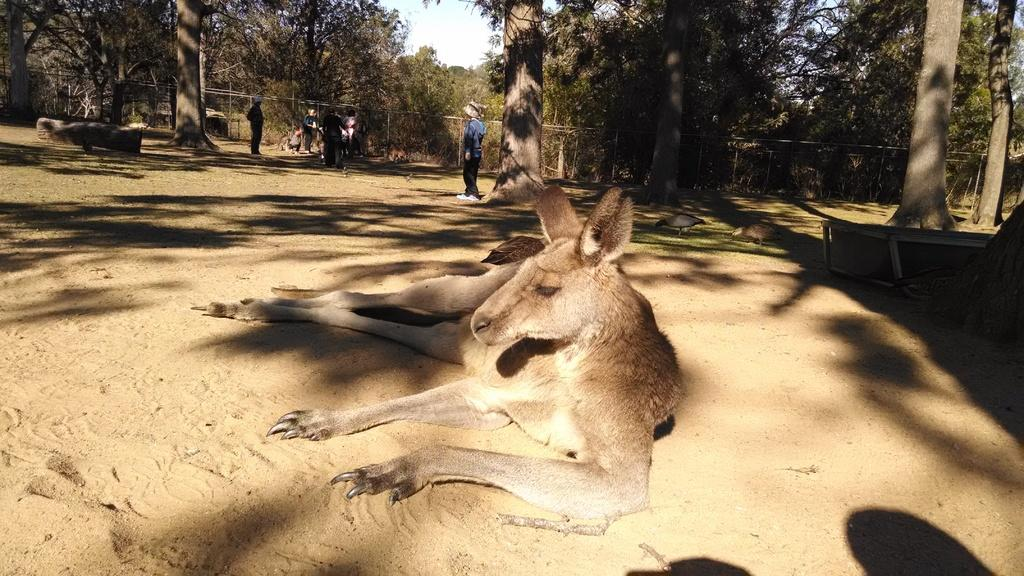What is the animal lying on the sand in the image? The animal lying on the sand is not specified in the facts provided. What other living creatures can be seen in the image? There are birds visible in the image. What are the persons standing on the sand doing? The actions of the persons standing on the sand are not specified in the facts provided. What structure is present in the image with a name on it? There is a name board in the image. What type of seating is available in the image? There are benches in the image. What type of barrier is present in the image? There is a wooden fence in the image. What type of vegetation is present in the image? There are trees in the image. What part of the natural environment is visible in the image? The sky is visible in the image. How many buns are being used as a pillow for the ghost in the image? There is no ghost or bun present in the image. What type of eggs are being cooked by the birds in the image? There are no eggs or cooking activity involving birds in the image. 